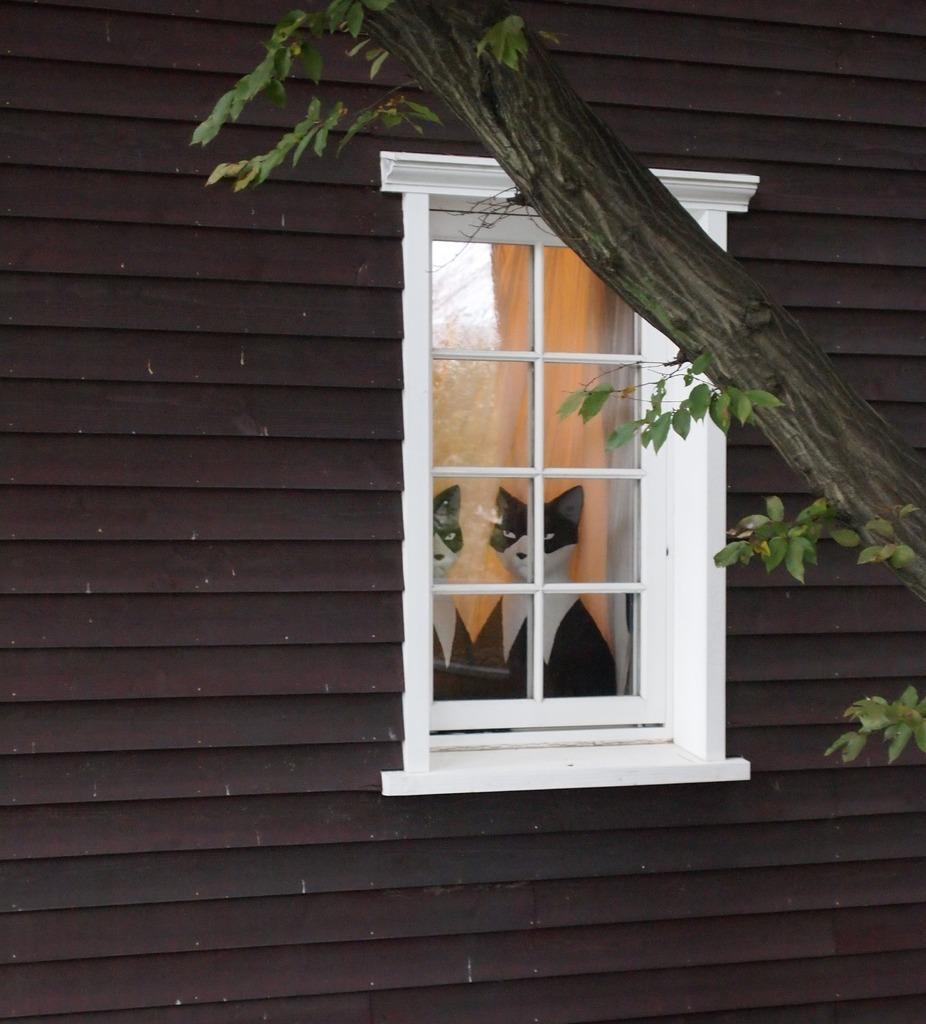Can you describe this image briefly? In the center of the image we can see a window. through window we can see a cat and its reflection. In the background of the image we can see the wall and tree. 